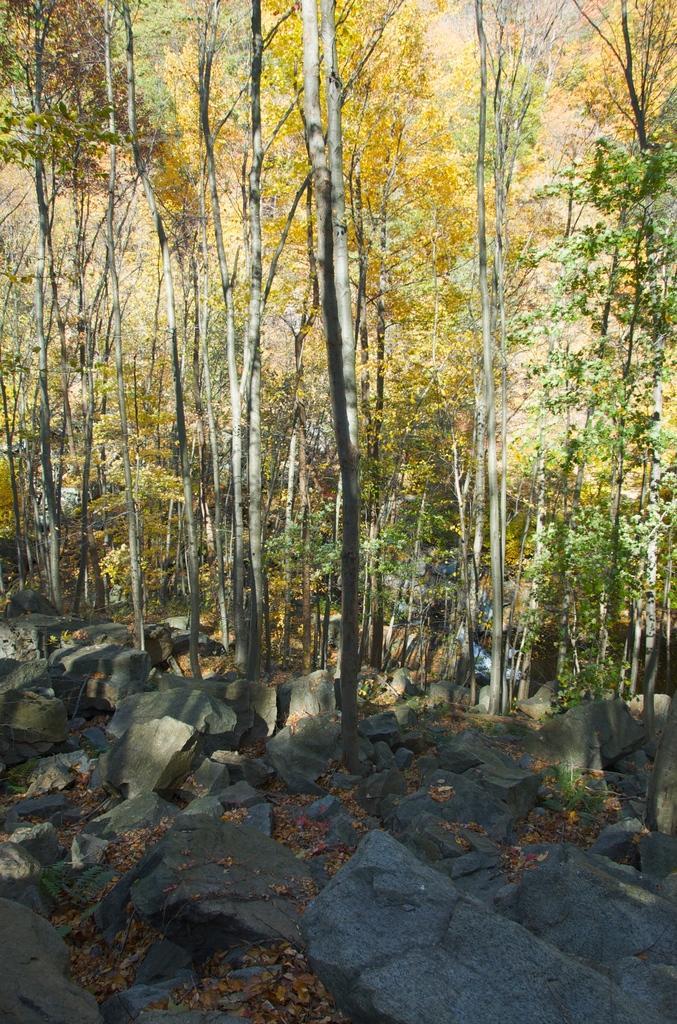Could you give a brief overview of what you see in this image? This image looks like it is clicked in a forest. There are many trees in background. At the bottom, there are rocks. 